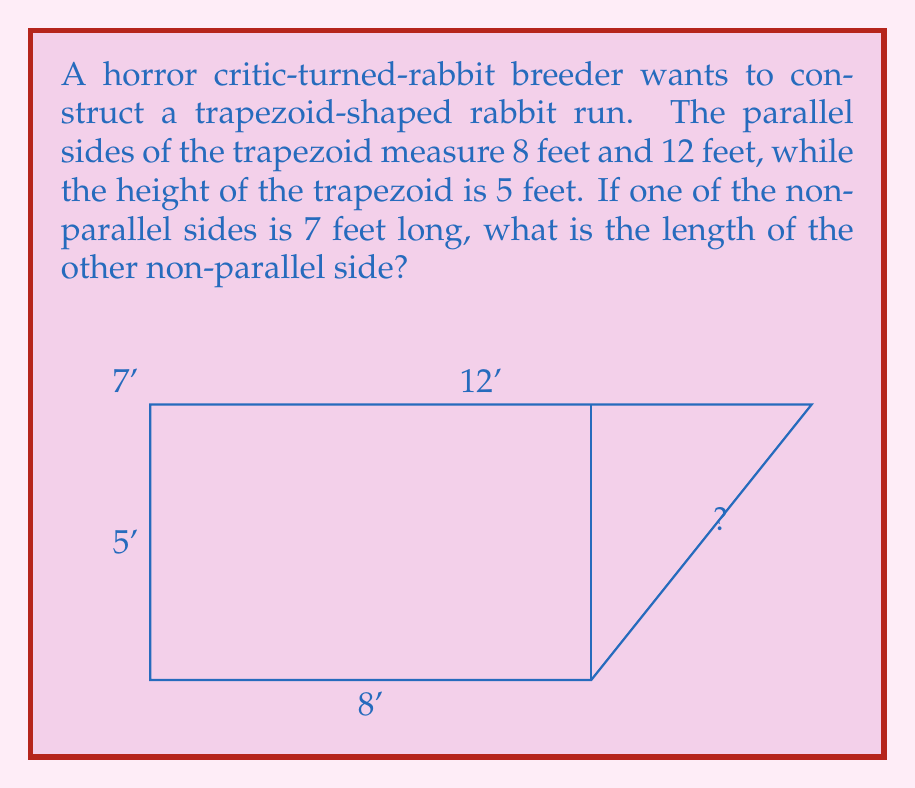Solve this math problem. To solve this problem, we'll use the Pythagorean theorem and the properties of trapezoids. Let's break it down step-by-step:

1) First, let's identify what we know:
   - The parallel sides are 8 feet and 12 feet
   - The height is 5 feet
   - One non-parallel side is 7 feet

2) Let's call the unknown side length $x$.

3) The difference between the parallel sides is 12 - 8 = 4 feet. This difference is split between the two sides of the trapezoid.

4) We can split the trapezoid into a rectangle and two right triangles. We need to find the base of these triangles.

5) Let the base of one triangle be $y$. Then the base of the other triangle is $4-y$.

6) For the known side (7 feet), we can use the Pythagorean theorem:
   $$7^2 = 5^2 + y^2$$
   $$49 = 25 + y^2$$
   $$y^2 = 24$$
   $$y = \sqrt{24} = 2\sqrt{6}$$

7) Now for the unknown side $x$, we can use the Pythagorean theorem again:
   $$x^2 = 5^2 + (4-y)^2$$
   $$x^2 = 25 + (4-2\sqrt{6})^2$$
   $$x^2 = 25 + 16 - 16\sqrt{6} + 24$$
   $$x^2 = 65 - 16\sqrt{6}$$

8) Taking the square root of both sides:
   $$x = \sqrt{65 - 16\sqrt{6}}$$

This is the exact answer. If we need to approximate:
$$x \approx 5.83 \text{ feet}$$
Answer: $\sqrt{65 - 16\sqrt{6}}$ feet 